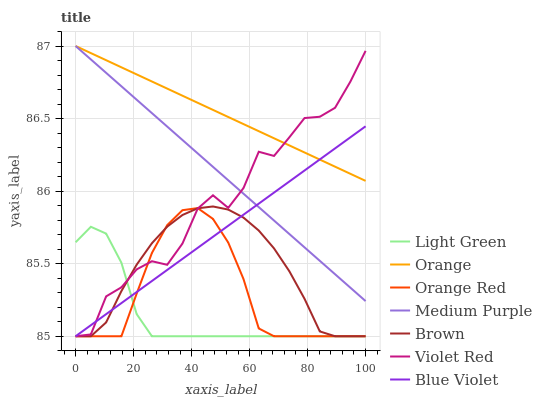Does Light Green have the minimum area under the curve?
Answer yes or no. Yes. Does Orange have the maximum area under the curve?
Answer yes or no. Yes. Does Violet Red have the minimum area under the curve?
Answer yes or no. No. Does Violet Red have the maximum area under the curve?
Answer yes or no. No. Is Orange the smoothest?
Answer yes or no. Yes. Is Violet Red the roughest?
Answer yes or no. Yes. Is Medium Purple the smoothest?
Answer yes or no. No. Is Medium Purple the roughest?
Answer yes or no. No. Does Brown have the lowest value?
Answer yes or no. Yes. Does Medium Purple have the lowest value?
Answer yes or no. No. Does Orange have the highest value?
Answer yes or no. Yes. Does Violet Red have the highest value?
Answer yes or no. No. Is Light Green less than Orange?
Answer yes or no. Yes. Is Medium Purple greater than Brown?
Answer yes or no. Yes. Does Violet Red intersect Medium Purple?
Answer yes or no. Yes. Is Violet Red less than Medium Purple?
Answer yes or no. No. Is Violet Red greater than Medium Purple?
Answer yes or no. No. Does Light Green intersect Orange?
Answer yes or no. No. 